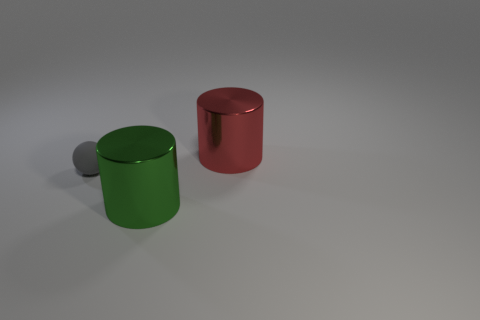Add 1 large red matte balls. How many objects exist? 4 Subtract all cylinders. How many objects are left? 1 Add 3 small balls. How many small balls are left? 4 Add 3 large shiny cylinders. How many large shiny cylinders exist? 5 Subtract 0 purple spheres. How many objects are left? 3 Subtract all small things. Subtract all tiny brown matte objects. How many objects are left? 2 